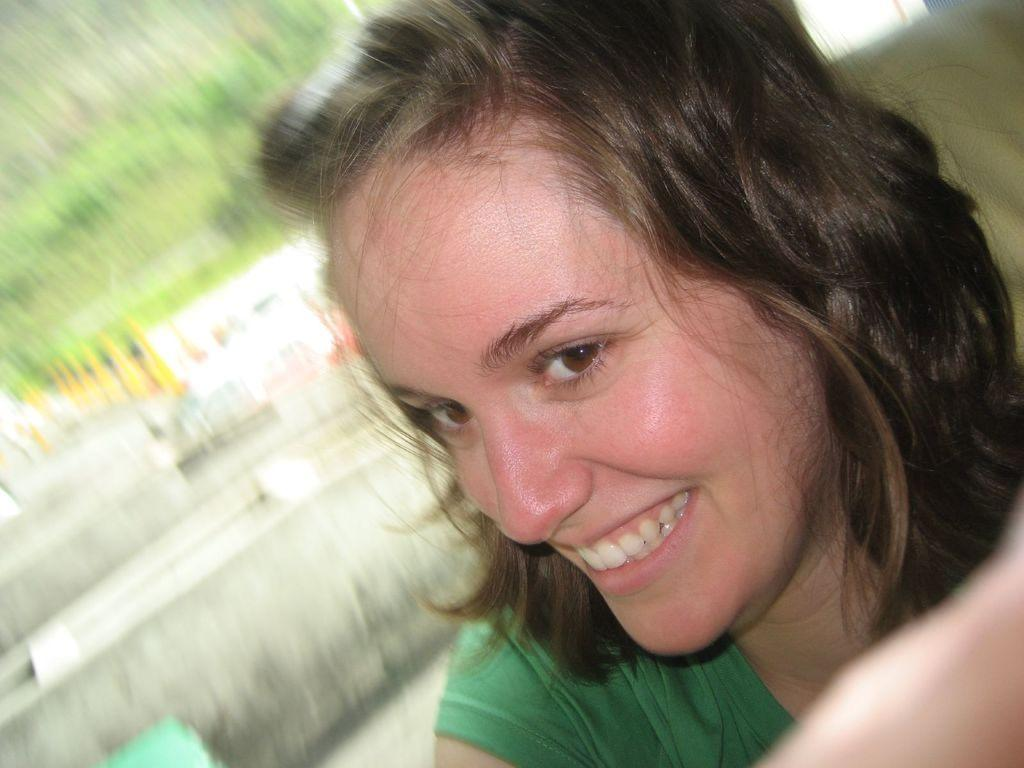What is present in the image? There is a person in the image. How is the person's facial expression? The person has a smiling face. Can you describe the background of the image? The background of the image is blurred. What type of cup is the goose attempting to drink from in the image? There is no goose or cup present in the image. 